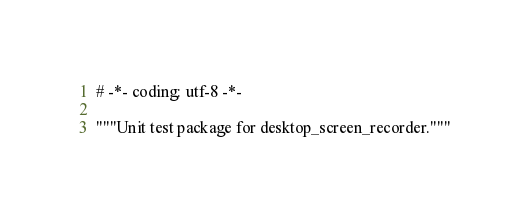Convert code to text. <code><loc_0><loc_0><loc_500><loc_500><_Python_># -*- coding: utf-8 -*-

"""Unit test package for desktop_screen_recorder."""
</code> 